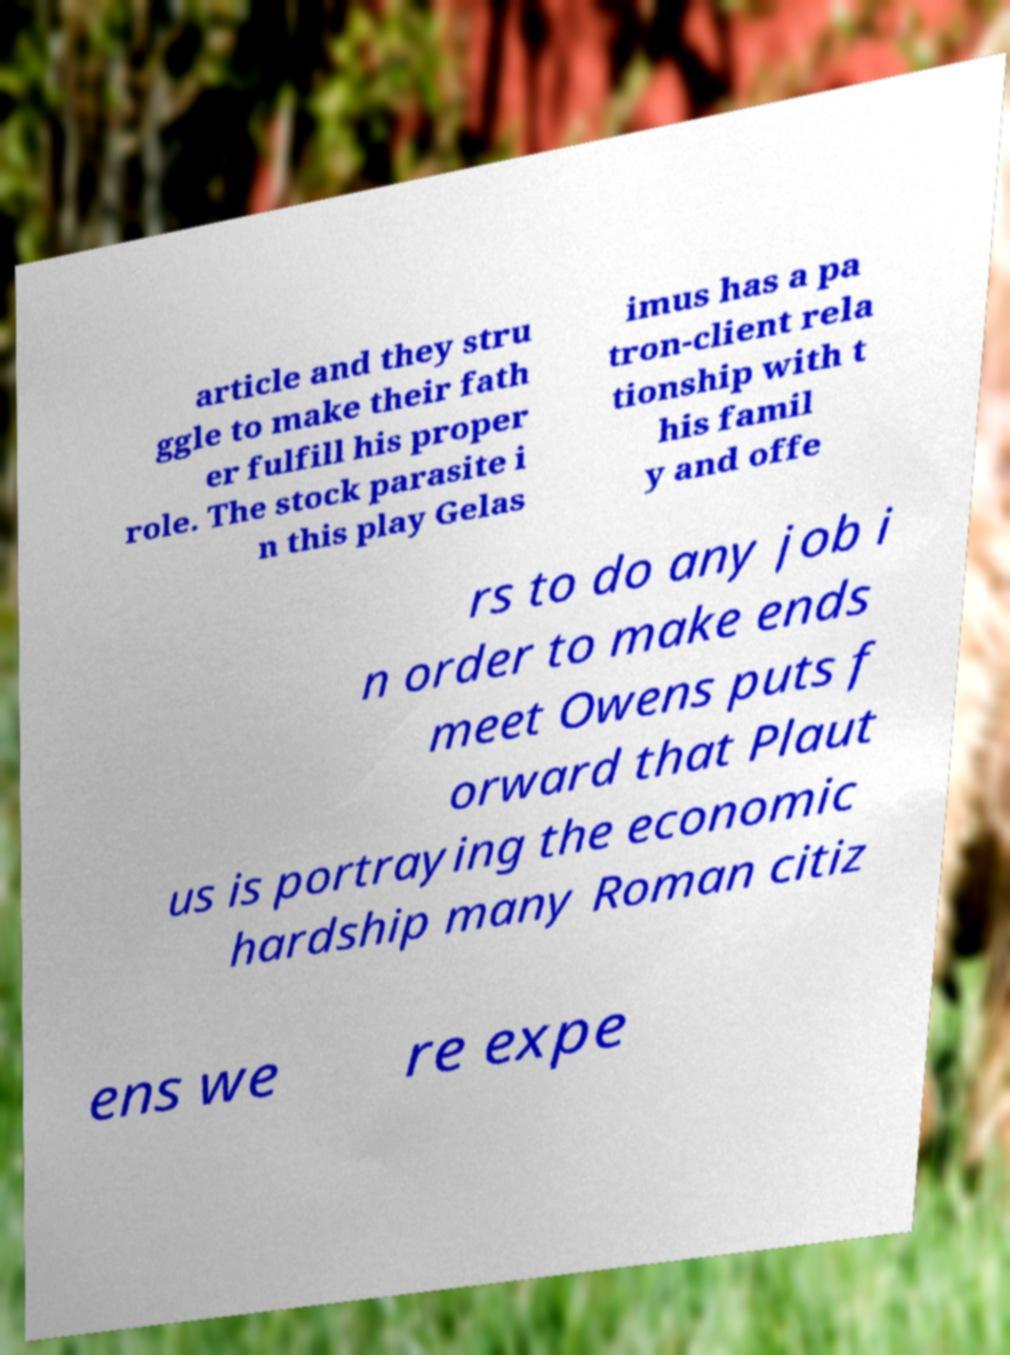Please read and relay the text visible in this image. What does it say? article and they stru ggle to make their fath er fulfill his proper role. The stock parasite i n this play Gelas imus has a pa tron-client rela tionship with t his famil y and offe rs to do any job i n order to make ends meet Owens puts f orward that Plaut us is portraying the economic hardship many Roman citiz ens we re expe 